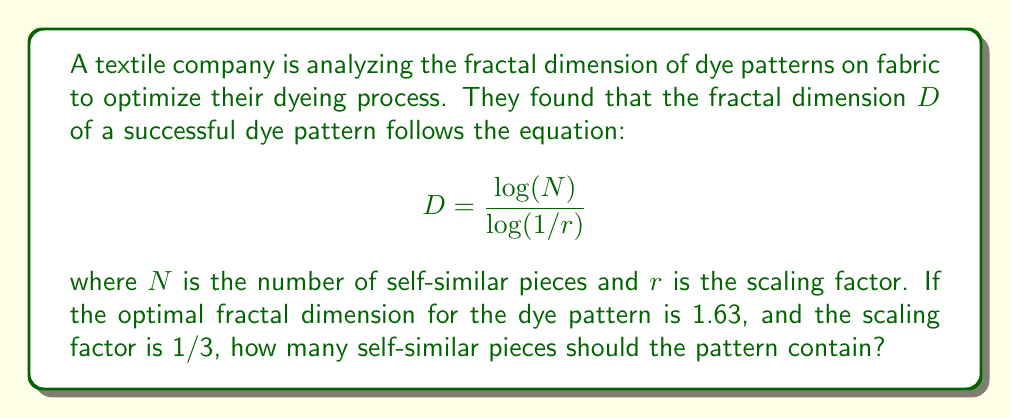Solve this math problem. To solve this problem, we'll follow these steps:

1) We are given the fractal dimension $D = 1.63$ and the scaling factor $r = 1/3$.

2) We need to find $N$, the number of self-similar pieces.

3) Let's start with the given equation:

   $$D = \frac{\log(N)}{\log(1/r)}$$

4) Substitute the known values:

   $$1.63 = \frac{\log(N)}{\log(3)}$$

5) Multiply both sides by $\log(3)$:

   $$1.63 \cdot \log(3) = \log(N)$$

6) Now, we need to solve for $N$. We can do this by applying the exponential function to both sides:

   $$e^{1.63 \cdot \log(3)} = e^{\log(N)}$$

7) Simplify the right side:

   $$e^{1.63 \cdot \log(3)} = N$$

8) Calculate the left side:
   
   $$3^{1.63} = N$$

9) Evaluate this (using a calculator):

   $$4.99 \approx N$$

10) Since $N$ must be a whole number, we round to the nearest integer:

    $$N = 5$$

Therefore, the pattern should contain 5 self-similar pieces to achieve the optimal fractal dimension.
Answer: 5 